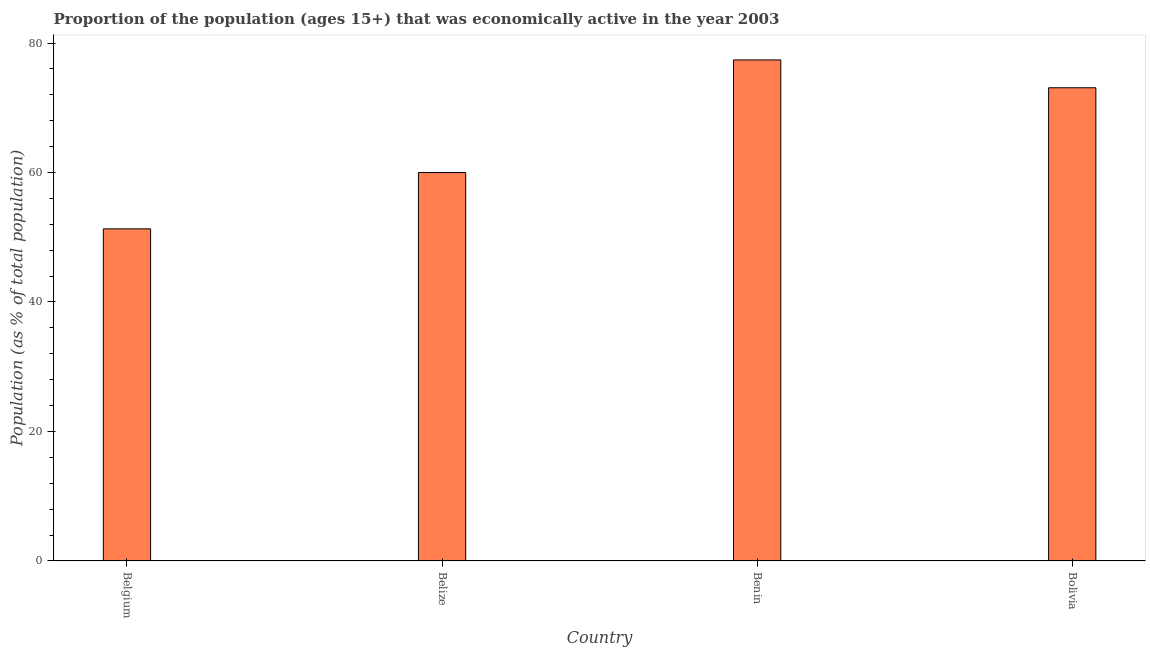What is the title of the graph?
Your answer should be very brief. Proportion of the population (ages 15+) that was economically active in the year 2003. What is the label or title of the Y-axis?
Offer a terse response. Population (as % of total population). What is the percentage of economically active population in Belgium?
Provide a short and direct response. 51.3. Across all countries, what is the maximum percentage of economically active population?
Offer a terse response. 77.4. Across all countries, what is the minimum percentage of economically active population?
Make the answer very short. 51.3. In which country was the percentage of economically active population maximum?
Ensure brevity in your answer.  Benin. What is the sum of the percentage of economically active population?
Offer a very short reply. 261.8. What is the average percentage of economically active population per country?
Give a very brief answer. 65.45. What is the median percentage of economically active population?
Your answer should be very brief. 66.55. What is the ratio of the percentage of economically active population in Belize to that in Benin?
Your response must be concise. 0.78. Is the difference between the percentage of economically active population in Belgium and Belize greater than the difference between any two countries?
Keep it short and to the point. No. Is the sum of the percentage of economically active population in Belgium and Belize greater than the maximum percentage of economically active population across all countries?
Keep it short and to the point. Yes. What is the difference between the highest and the lowest percentage of economically active population?
Make the answer very short. 26.1. Are all the bars in the graph horizontal?
Provide a short and direct response. No. What is the difference between two consecutive major ticks on the Y-axis?
Your answer should be very brief. 20. What is the Population (as % of total population) of Belgium?
Ensure brevity in your answer.  51.3. What is the Population (as % of total population) in Belize?
Make the answer very short. 60. What is the Population (as % of total population) in Benin?
Provide a short and direct response. 77.4. What is the Population (as % of total population) in Bolivia?
Provide a short and direct response. 73.1. What is the difference between the Population (as % of total population) in Belgium and Benin?
Give a very brief answer. -26.1. What is the difference between the Population (as % of total population) in Belgium and Bolivia?
Make the answer very short. -21.8. What is the difference between the Population (as % of total population) in Belize and Benin?
Your response must be concise. -17.4. What is the difference between the Population (as % of total population) in Belize and Bolivia?
Your answer should be very brief. -13.1. What is the ratio of the Population (as % of total population) in Belgium to that in Belize?
Your response must be concise. 0.85. What is the ratio of the Population (as % of total population) in Belgium to that in Benin?
Your answer should be very brief. 0.66. What is the ratio of the Population (as % of total population) in Belgium to that in Bolivia?
Your answer should be compact. 0.7. What is the ratio of the Population (as % of total population) in Belize to that in Benin?
Offer a terse response. 0.78. What is the ratio of the Population (as % of total population) in Belize to that in Bolivia?
Keep it short and to the point. 0.82. What is the ratio of the Population (as % of total population) in Benin to that in Bolivia?
Offer a very short reply. 1.06. 